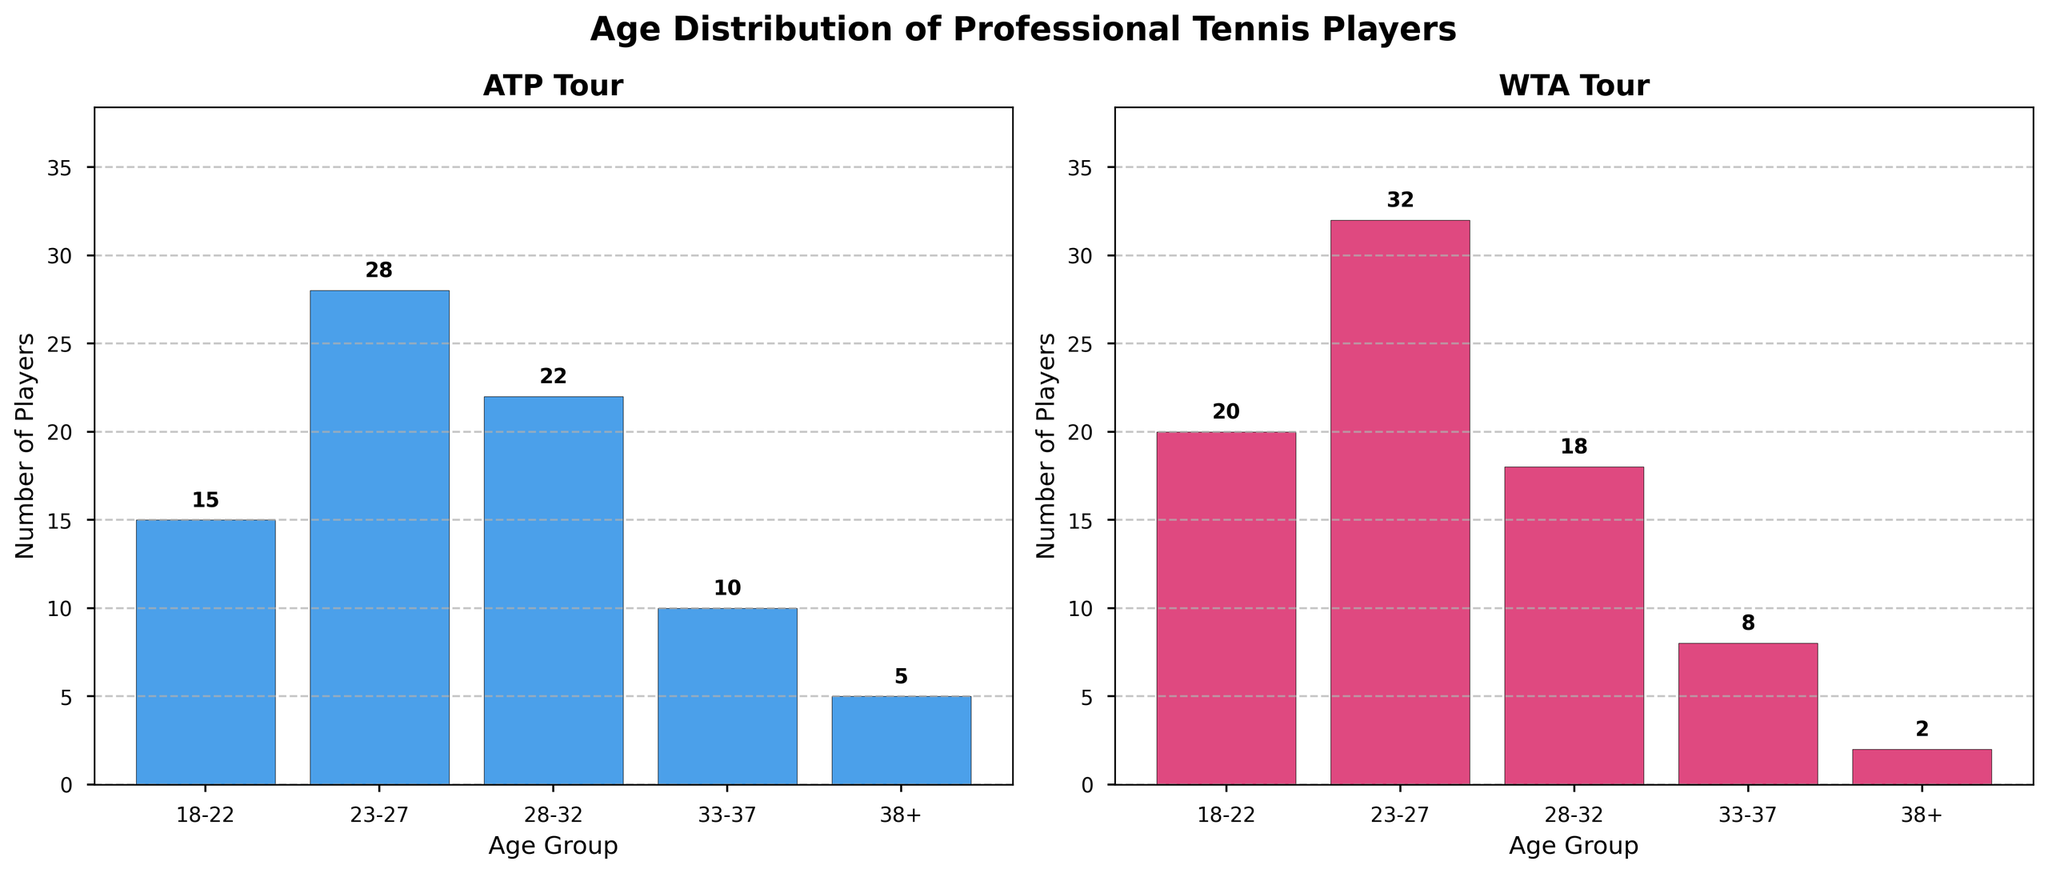What is the title of the figure? The title is located at the top center of the figure and reads 'Age Distribution of Professional Tennis Players'.
Answer: Age Distribution of Professional Tennis Players Which age group has the highest number of players on the ATP tour? By observing the ATP subplot, the bar representing the age group 23-27 is the tallest, indicating the highest number of players.
Answer: 23-27 How many players in total are there on the ATP tour? Adding the counts for each age group (15 + 28 + 22 + 10 + 5), the total number of players on the ATP tour is 80.
Answer: 80 Which tour has more players in the 28-32 age group? By comparing the heights of the bars for age group 28-32 in both subplots, it is evident that the ATP tour has more players than the WTA tour (22 vs. 18).
Answer: ATP What is the difference in the number of players aged 33-37 between the ATP and WTA tours? The ATP tour has 10 players in this age group, while the WTA tour has 8. The difference is 10 - 8 = 2.
Answer: 2 Which age group on the WTA tour has the smallest number of players? The smallest bar in the WTA subplot corresponds to the age group 38+, indicating only 2 players.
Answer: 38+ What is the sum of players aged 18-27 on the WTA tour? Summing the counts for age groups 18-22 and 23-27 on the WTA subplot (20 + 32), the total is 52.
Answer: 52 Are there more players aged 33-37 on the ATP tour or players aged 18-22 on the WTA tour? Comparing the bars for these age groups in their respective subplots, there are 15 players aged 18-22 on WTA, and 10 players aged 33-37 on ATP. So, there are more players aged 18-22 on the WTA tour.
Answer: WTA 18-22 What is the difference in the total number of players between the ATP and WTA tours? The total number for the ATP tour is 80, and for the WTA tour, it is (20 + 32 + 18 + 8 + 2) = 80. So, the difference is 0.
Answer: 0 Which tour has more players overall in the age group 38+? Comparing the bars for age group 38+ in both subplots, the ATP tour has 5 players, while the WTA tour has 2 players. Hence, ATP has more players in this group.
Answer: ATP 